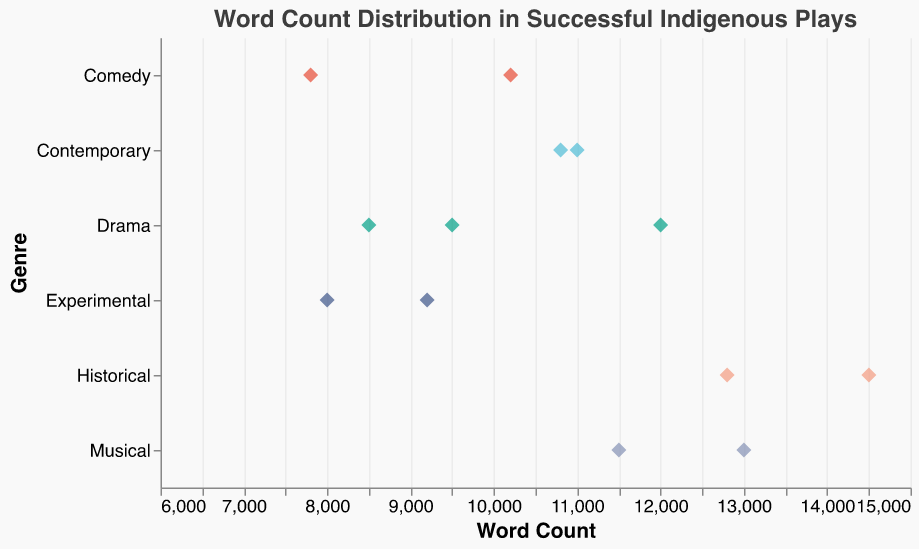How many plays are classified under the "Comedy" genre? By looking along the y-axis, we can see that there are two points corresponding to the Comedy genre.
Answer: 2 What is the title of the play with the highest word count? The play with the highest word count is depicted by the point farthest to the right on the x-axis. This corresponds to "Stolen" with a word count of 14500.
Answer: Stolen What is the average word count for the plays in the "Drama" genre? There are three plays listed under the Drama genre: "The 7 Stages of Grieving" (8500 words), "Radiance" (12000 words), and "Box the Pony" (9500 words). Their total word count is 8500 + 12000 + 9500 = 30000. The average word count is 30000 / 3 = 10000.
Answer: 10000 Which genre has the most number of plays with word counts above 10000? By checking the positions of each point above the 10000 mark on the x-axis and counting the corresponding genres, we can see the genres and their counts: Drama (1), Comedy (1), Musical (2), and Historical (2). Both Musical and Historical genres have 2 plays above 10000.
Answer: Musical and Historical Which genre shows the widest range of word counts? The range of word counts for each genre can be observed by looking at the spread of points along the x-axis. The Historical genre has points from 12800 to 14500, representing a range of 1700, the widest among the displayed genres.
Answer: Historical What is the word count of "City of Gold"? By finding the tooltip associated with "City of Gold," the word count is displayed as 10800.
Answer: 10800 Compare the word counts of "Radiance" and "Bran Nue Dae". Which one is higher and by how much? "Radiance" has a word count of 12000, and "Bran Nue Dae" has a word count of 11500. The difference is 12000 - 11500 = 500, indicating that "Radiance" has 500 more words than "Bran Nue Dae".
Answer: Radiance, 500 Which experimental play has the lower word count? By comparing the points under the Experimental genre, we see "The Drovers Wife" (9200 words) and "Bindjareb Pinjarra" (8000 words). "Bindjareb Pinjarra" has the lower word count.
Answer: Bindjareb Pinjarra What is the median word count for all the plays in the plot? First, list all word counts in ascending order: 7800, 8000, 8500, 9200, 9500, 10200, 10800, 11000, 11500, 12000, 12800, 13000, 14500. The median is the middle value of this list, which is the 7th value: 10800.
Answer: 10800 